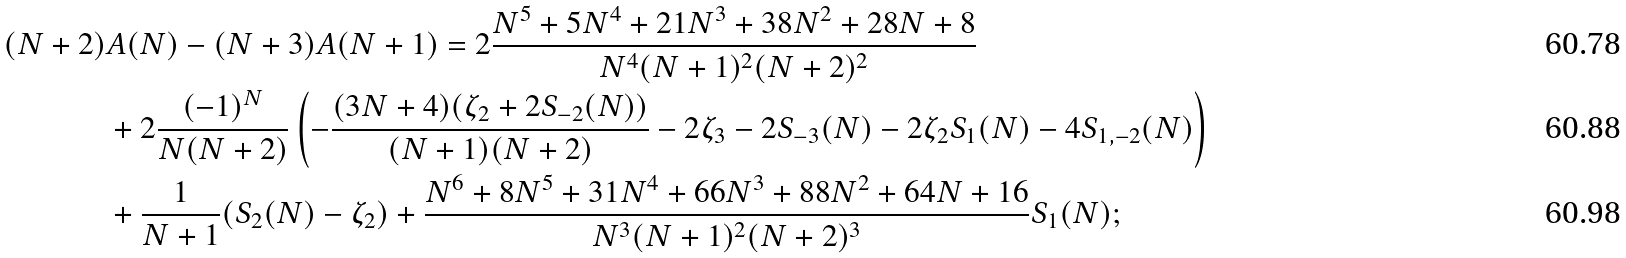Convert formula to latex. <formula><loc_0><loc_0><loc_500><loc_500>( N + 2 ) & A ( N ) - ( N + 3 ) A ( N + 1 ) = 2 \frac { N ^ { 5 } + 5 N ^ { 4 } + 2 1 N ^ { 3 } + 3 8 N ^ { 2 } + 2 8 N + 8 } { N ^ { 4 } ( N + 1 ) ^ { 2 } ( N + 2 ) ^ { 2 } } \\ & + 2 \frac { ( - 1 ) ^ { N } } { N ( N + 2 ) } \left ( - \frac { ( 3 N + 4 ) ( \zeta _ { 2 } + 2 S _ { - 2 } ( N ) ) } { ( N + 1 ) ( N + 2 ) } - 2 \zeta _ { 3 } - 2 S _ { - 3 } ( N ) - 2 \zeta _ { 2 } S _ { 1 } ( N ) - 4 S _ { 1 , - 2 } ( N ) \right ) \\ & + \frac { 1 } { N + 1 } ( S _ { 2 } ( N ) - \zeta _ { 2 } ) + \frac { N ^ { 6 } + 8 N ^ { 5 } + 3 1 N ^ { 4 } + 6 6 N ^ { 3 } + 8 8 N ^ { 2 } + 6 4 N + 1 6 } { N ^ { 3 } ( N + 1 ) ^ { 2 } ( N + 2 ) ^ { 3 } } S _ { 1 } ( N ) ;</formula> 